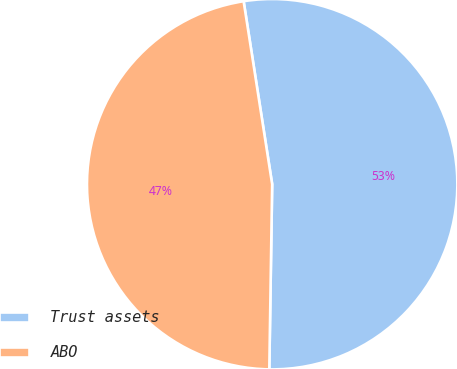Convert chart. <chart><loc_0><loc_0><loc_500><loc_500><pie_chart><fcel>Trust assets<fcel>ABO<nl><fcel>52.71%<fcel>47.29%<nl></chart> 